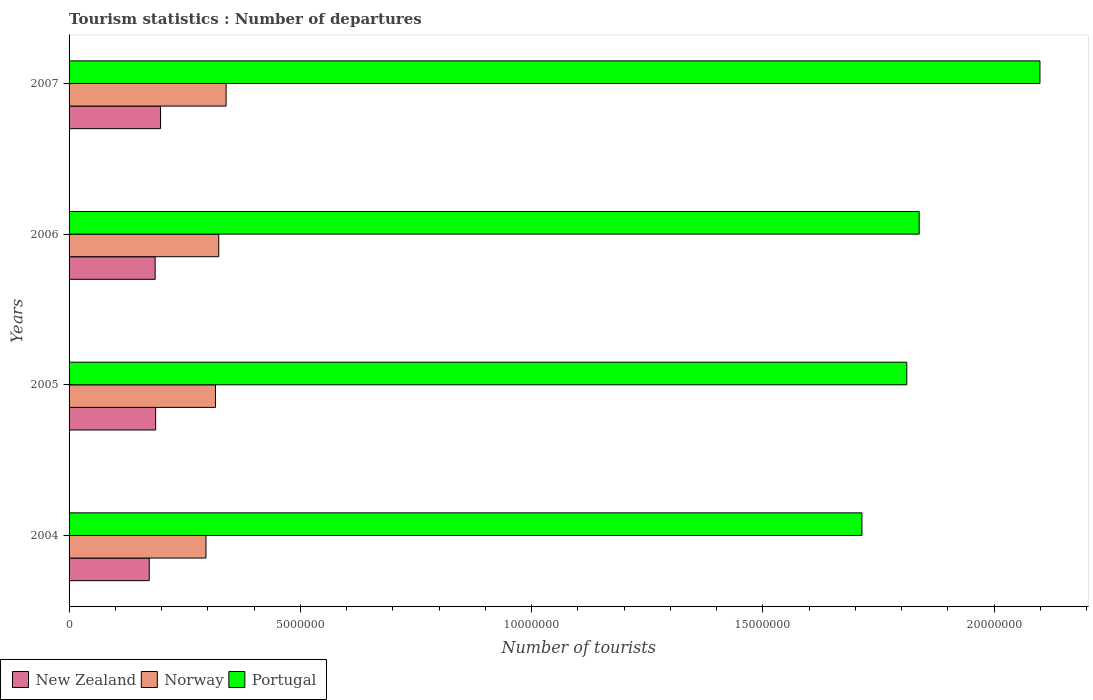How many groups of bars are there?
Your answer should be very brief. 4. Are the number of bars per tick equal to the number of legend labels?
Your response must be concise. Yes. How many bars are there on the 1st tick from the bottom?
Offer a terse response. 3. In how many cases, is the number of bars for a given year not equal to the number of legend labels?
Offer a very short reply. 0. What is the number of tourist departures in Norway in 2006?
Make the answer very short. 3.24e+06. Across all years, what is the maximum number of tourist departures in Norway?
Offer a terse response. 3.40e+06. Across all years, what is the minimum number of tourist departures in Norway?
Your response must be concise. 2.96e+06. In which year was the number of tourist departures in New Zealand maximum?
Provide a short and direct response. 2007. What is the total number of tourist departures in Norway in the graph?
Provide a succinct answer. 1.28e+07. What is the difference between the number of tourist departures in Norway in 2004 and that in 2006?
Ensure brevity in your answer.  -2.76e+05. What is the difference between the number of tourist departures in Norway in 2004 and the number of tourist departures in Portugal in 2005?
Provide a short and direct response. -1.52e+07. What is the average number of tourist departures in Portugal per year?
Your answer should be very brief. 1.87e+07. In the year 2004, what is the difference between the number of tourist departures in New Zealand and number of tourist departures in Portugal?
Your answer should be very brief. -1.54e+07. What is the ratio of the number of tourist departures in New Zealand in 2004 to that in 2005?
Your answer should be very brief. 0.93. Is the difference between the number of tourist departures in New Zealand in 2005 and 2007 greater than the difference between the number of tourist departures in Portugal in 2005 and 2007?
Your answer should be compact. Yes. What is the difference between the highest and the second highest number of tourist departures in Portugal?
Offer a very short reply. 2.61e+06. What is the difference between the highest and the lowest number of tourist departures in New Zealand?
Offer a terse response. 2.45e+05. What does the 1st bar from the bottom in 2005 represents?
Your answer should be compact. New Zealand. Is it the case that in every year, the sum of the number of tourist departures in New Zealand and number of tourist departures in Portugal is greater than the number of tourist departures in Norway?
Offer a terse response. Yes. Are all the bars in the graph horizontal?
Make the answer very short. Yes. How many years are there in the graph?
Offer a very short reply. 4. What is the difference between two consecutive major ticks on the X-axis?
Provide a succinct answer. 5.00e+06. Are the values on the major ticks of X-axis written in scientific E-notation?
Provide a succinct answer. No. Does the graph contain any zero values?
Your answer should be very brief. No. Does the graph contain grids?
Keep it short and to the point. No. How many legend labels are there?
Offer a very short reply. 3. What is the title of the graph?
Make the answer very short. Tourism statistics : Number of departures. What is the label or title of the X-axis?
Keep it short and to the point. Number of tourists. What is the label or title of the Y-axis?
Provide a succinct answer. Years. What is the Number of tourists in New Zealand in 2004?
Offer a terse response. 1.73e+06. What is the Number of tourists in Norway in 2004?
Your answer should be compact. 2.96e+06. What is the Number of tourists of Portugal in 2004?
Ensure brevity in your answer.  1.71e+07. What is the Number of tourists in New Zealand in 2005?
Your answer should be compact. 1.87e+06. What is the Number of tourists of Norway in 2005?
Your response must be concise. 3.17e+06. What is the Number of tourists in Portugal in 2005?
Your answer should be very brief. 1.81e+07. What is the Number of tourists in New Zealand in 2006?
Your answer should be very brief. 1.86e+06. What is the Number of tourists of Norway in 2006?
Offer a very short reply. 3.24e+06. What is the Number of tourists of Portugal in 2006?
Ensure brevity in your answer.  1.84e+07. What is the Number of tourists in New Zealand in 2007?
Your answer should be very brief. 1.98e+06. What is the Number of tourists in Norway in 2007?
Offer a very short reply. 3.40e+06. What is the Number of tourists in Portugal in 2007?
Ensure brevity in your answer.  2.10e+07. Across all years, what is the maximum Number of tourists in New Zealand?
Your answer should be compact. 1.98e+06. Across all years, what is the maximum Number of tourists of Norway?
Ensure brevity in your answer.  3.40e+06. Across all years, what is the maximum Number of tourists in Portugal?
Offer a very short reply. 2.10e+07. Across all years, what is the minimum Number of tourists in New Zealand?
Provide a succinct answer. 1.73e+06. Across all years, what is the minimum Number of tourists in Norway?
Give a very brief answer. 2.96e+06. Across all years, what is the minimum Number of tourists of Portugal?
Offer a terse response. 1.71e+07. What is the total Number of tourists of New Zealand in the graph?
Provide a short and direct response. 7.44e+06. What is the total Number of tourists in Norway in the graph?
Your answer should be very brief. 1.28e+07. What is the total Number of tourists in Portugal in the graph?
Ensure brevity in your answer.  7.46e+07. What is the difference between the Number of tourists in New Zealand in 2004 and that in 2005?
Make the answer very short. -1.39e+05. What is the difference between the Number of tourists of Norway in 2004 and that in 2005?
Keep it short and to the point. -2.06e+05. What is the difference between the Number of tourists of Portugal in 2004 and that in 2005?
Your answer should be compact. -9.69e+05. What is the difference between the Number of tourists of New Zealand in 2004 and that in 2006?
Your answer should be very brief. -1.28e+05. What is the difference between the Number of tourists of Norway in 2004 and that in 2006?
Your response must be concise. -2.76e+05. What is the difference between the Number of tourists in Portugal in 2004 and that in 2006?
Your answer should be very brief. -1.24e+06. What is the difference between the Number of tourists in New Zealand in 2004 and that in 2007?
Your response must be concise. -2.45e+05. What is the difference between the Number of tourists in Norway in 2004 and that in 2007?
Give a very brief answer. -4.35e+05. What is the difference between the Number of tourists in Portugal in 2004 and that in 2007?
Provide a short and direct response. -3.85e+06. What is the difference between the Number of tourists of New Zealand in 2005 and that in 2006?
Your answer should be compact. 1.10e+04. What is the difference between the Number of tourists of Portugal in 2005 and that in 2006?
Provide a succinct answer. -2.68e+05. What is the difference between the Number of tourists in New Zealand in 2005 and that in 2007?
Provide a short and direct response. -1.06e+05. What is the difference between the Number of tourists in Norway in 2005 and that in 2007?
Your answer should be very brief. -2.29e+05. What is the difference between the Number of tourists of Portugal in 2005 and that in 2007?
Keep it short and to the point. -2.88e+06. What is the difference between the Number of tourists of New Zealand in 2006 and that in 2007?
Your answer should be compact. -1.17e+05. What is the difference between the Number of tourists of Norway in 2006 and that in 2007?
Offer a terse response. -1.59e+05. What is the difference between the Number of tourists of Portugal in 2006 and that in 2007?
Offer a terse response. -2.61e+06. What is the difference between the Number of tourists in New Zealand in 2004 and the Number of tourists in Norway in 2005?
Offer a very short reply. -1.43e+06. What is the difference between the Number of tourists in New Zealand in 2004 and the Number of tourists in Portugal in 2005?
Offer a terse response. -1.64e+07. What is the difference between the Number of tourists in Norway in 2004 and the Number of tourists in Portugal in 2005?
Your answer should be very brief. -1.52e+07. What is the difference between the Number of tourists of New Zealand in 2004 and the Number of tourists of Norway in 2006?
Give a very brief answer. -1.50e+06. What is the difference between the Number of tourists in New Zealand in 2004 and the Number of tourists in Portugal in 2006?
Keep it short and to the point. -1.66e+07. What is the difference between the Number of tourists of Norway in 2004 and the Number of tourists of Portugal in 2006?
Offer a terse response. -1.54e+07. What is the difference between the Number of tourists in New Zealand in 2004 and the Number of tourists in Norway in 2007?
Provide a succinct answer. -1.66e+06. What is the difference between the Number of tourists of New Zealand in 2004 and the Number of tourists of Portugal in 2007?
Give a very brief answer. -1.93e+07. What is the difference between the Number of tourists in Norway in 2004 and the Number of tourists in Portugal in 2007?
Keep it short and to the point. -1.80e+07. What is the difference between the Number of tourists in New Zealand in 2005 and the Number of tourists in Norway in 2006?
Ensure brevity in your answer.  -1.36e+06. What is the difference between the Number of tourists in New Zealand in 2005 and the Number of tourists in Portugal in 2006?
Offer a very short reply. -1.65e+07. What is the difference between the Number of tourists of Norway in 2005 and the Number of tourists of Portugal in 2006?
Your answer should be very brief. -1.52e+07. What is the difference between the Number of tourists of New Zealand in 2005 and the Number of tourists of Norway in 2007?
Make the answer very short. -1.52e+06. What is the difference between the Number of tourists of New Zealand in 2005 and the Number of tourists of Portugal in 2007?
Keep it short and to the point. -1.91e+07. What is the difference between the Number of tourists in Norway in 2005 and the Number of tourists in Portugal in 2007?
Ensure brevity in your answer.  -1.78e+07. What is the difference between the Number of tourists of New Zealand in 2006 and the Number of tourists of Norway in 2007?
Your answer should be compact. -1.53e+06. What is the difference between the Number of tourists of New Zealand in 2006 and the Number of tourists of Portugal in 2007?
Offer a very short reply. -1.91e+07. What is the difference between the Number of tourists in Norway in 2006 and the Number of tourists in Portugal in 2007?
Your answer should be compact. -1.78e+07. What is the average Number of tourists in New Zealand per year?
Offer a very short reply. 1.86e+06. What is the average Number of tourists of Norway per year?
Make the answer very short. 3.19e+06. What is the average Number of tourists in Portugal per year?
Offer a very short reply. 1.87e+07. In the year 2004, what is the difference between the Number of tourists of New Zealand and Number of tourists of Norway?
Provide a succinct answer. -1.23e+06. In the year 2004, what is the difference between the Number of tourists of New Zealand and Number of tourists of Portugal?
Offer a terse response. -1.54e+07. In the year 2004, what is the difference between the Number of tourists in Norway and Number of tourists in Portugal?
Offer a very short reply. -1.42e+07. In the year 2005, what is the difference between the Number of tourists of New Zealand and Number of tourists of Norway?
Offer a terse response. -1.29e+06. In the year 2005, what is the difference between the Number of tourists of New Zealand and Number of tourists of Portugal?
Your answer should be very brief. -1.62e+07. In the year 2005, what is the difference between the Number of tourists of Norway and Number of tourists of Portugal?
Your answer should be very brief. -1.49e+07. In the year 2006, what is the difference between the Number of tourists of New Zealand and Number of tourists of Norway?
Ensure brevity in your answer.  -1.38e+06. In the year 2006, what is the difference between the Number of tourists of New Zealand and Number of tourists of Portugal?
Make the answer very short. -1.65e+07. In the year 2006, what is the difference between the Number of tourists of Norway and Number of tourists of Portugal?
Provide a succinct answer. -1.51e+07. In the year 2007, what is the difference between the Number of tourists in New Zealand and Number of tourists in Norway?
Provide a succinct answer. -1.42e+06. In the year 2007, what is the difference between the Number of tourists of New Zealand and Number of tourists of Portugal?
Ensure brevity in your answer.  -1.90e+07. In the year 2007, what is the difference between the Number of tourists of Norway and Number of tourists of Portugal?
Give a very brief answer. -1.76e+07. What is the ratio of the Number of tourists in New Zealand in 2004 to that in 2005?
Keep it short and to the point. 0.93. What is the ratio of the Number of tourists in Norway in 2004 to that in 2005?
Your answer should be very brief. 0.93. What is the ratio of the Number of tourists of Portugal in 2004 to that in 2005?
Ensure brevity in your answer.  0.95. What is the ratio of the Number of tourists in New Zealand in 2004 to that in 2006?
Offer a very short reply. 0.93. What is the ratio of the Number of tourists in Norway in 2004 to that in 2006?
Keep it short and to the point. 0.91. What is the ratio of the Number of tourists in Portugal in 2004 to that in 2006?
Your answer should be compact. 0.93. What is the ratio of the Number of tourists in New Zealand in 2004 to that in 2007?
Your answer should be compact. 0.88. What is the ratio of the Number of tourists in Norway in 2004 to that in 2007?
Make the answer very short. 0.87. What is the ratio of the Number of tourists of Portugal in 2004 to that in 2007?
Offer a very short reply. 0.82. What is the ratio of the Number of tourists in New Zealand in 2005 to that in 2006?
Your response must be concise. 1.01. What is the ratio of the Number of tourists of Norway in 2005 to that in 2006?
Provide a succinct answer. 0.98. What is the ratio of the Number of tourists in Portugal in 2005 to that in 2006?
Offer a terse response. 0.99. What is the ratio of the Number of tourists in New Zealand in 2005 to that in 2007?
Give a very brief answer. 0.95. What is the ratio of the Number of tourists in Norway in 2005 to that in 2007?
Ensure brevity in your answer.  0.93. What is the ratio of the Number of tourists of Portugal in 2005 to that in 2007?
Give a very brief answer. 0.86. What is the ratio of the Number of tourists of New Zealand in 2006 to that in 2007?
Provide a succinct answer. 0.94. What is the ratio of the Number of tourists of Norway in 2006 to that in 2007?
Your response must be concise. 0.95. What is the ratio of the Number of tourists of Portugal in 2006 to that in 2007?
Provide a short and direct response. 0.88. What is the difference between the highest and the second highest Number of tourists of New Zealand?
Offer a very short reply. 1.06e+05. What is the difference between the highest and the second highest Number of tourists of Norway?
Your answer should be compact. 1.59e+05. What is the difference between the highest and the second highest Number of tourists of Portugal?
Offer a terse response. 2.61e+06. What is the difference between the highest and the lowest Number of tourists of New Zealand?
Make the answer very short. 2.45e+05. What is the difference between the highest and the lowest Number of tourists in Norway?
Ensure brevity in your answer.  4.35e+05. What is the difference between the highest and the lowest Number of tourists of Portugal?
Keep it short and to the point. 3.85e+06. 